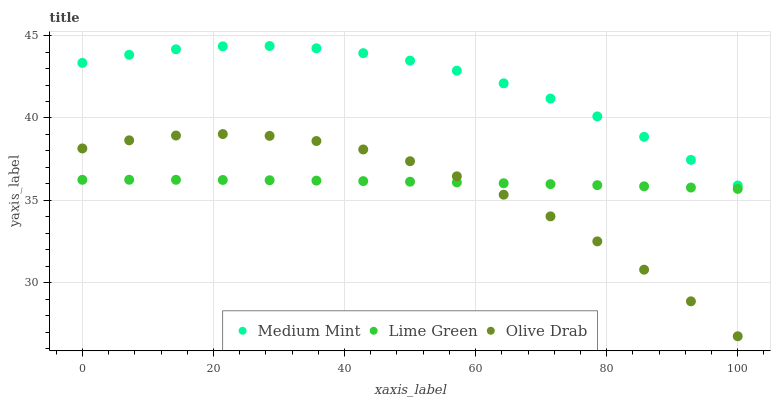Does Olive Drab have the minimum area under the curve?
Answer yes or no. Yes. Does Medium Mint have the maximum area under the curve?
Answer yes or no. Yes. Does Lime Green have the minimum area under the curve?
Answer yes or no. No. Does Lime Green have the maximum area under the curve?
Answer yes or no. No. Is Lime Green the smoothest?
Answer yes or no. Yes. Is Olive Drab the roughest?
Answer yes or no. Yes. Is Olive Drab the smoothest?
Answer yes or no. No. Is Lime Green the roughest?
Answer yes or no. No. Does Olive Drab have the lowest value?
Answer yes or no. Yes. Does Lime Green have the lowest value?
Answer yes or no. No. Does Medium Mint have the highest value?
Answer yes or no. Yes. Does Olive Drab have the highest value?
Answer yes or no. No. Is Olive Drab less than Medium Mint?
Answer yes or no. Yes. Is Medium Mint greater than Lime Green?
Answer yes or no. Yes. Does Lime Green intersect Olive Drab?
Answer yes or no. Yes. Is Lime Green less than Olive Drab?
Answer yes or no. No. Is Lime Green greater than Olive Drab?
Answer yes or no. No. Does Olive Drab intersect Medium Mint?
Answer yes or no. No. 